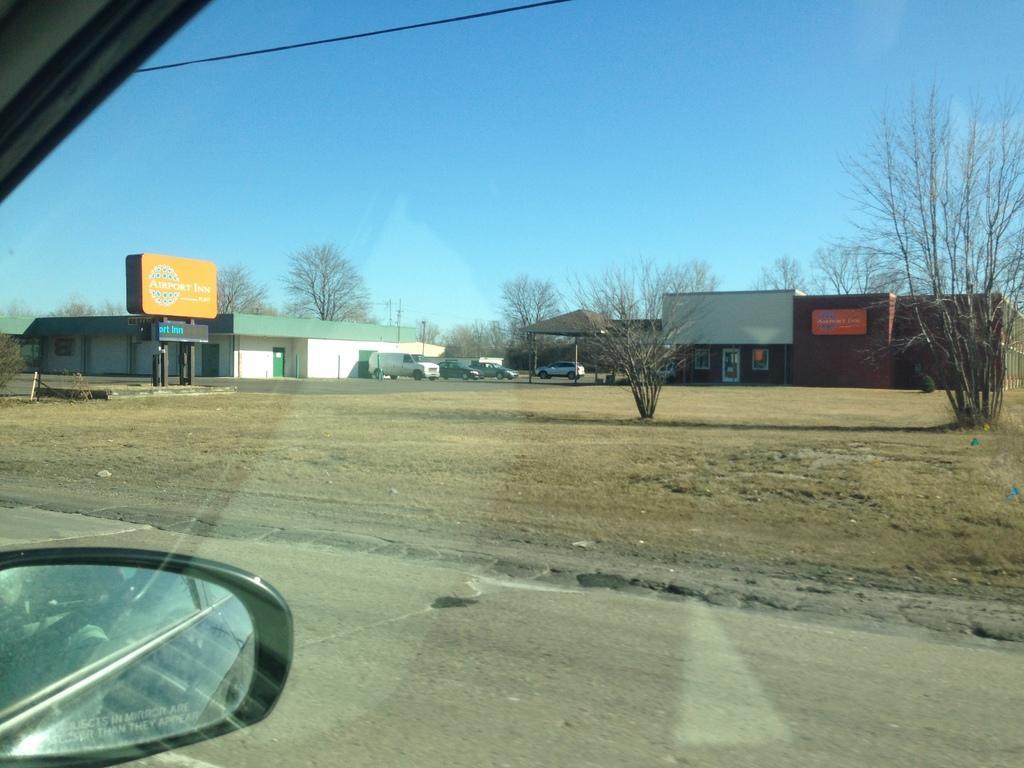Please provide a concise description of this image. In the image we can see there are many vehicles and trees. Here we can see the shed, road and dry grass. Here we can see electric wire, poster and the sky. 